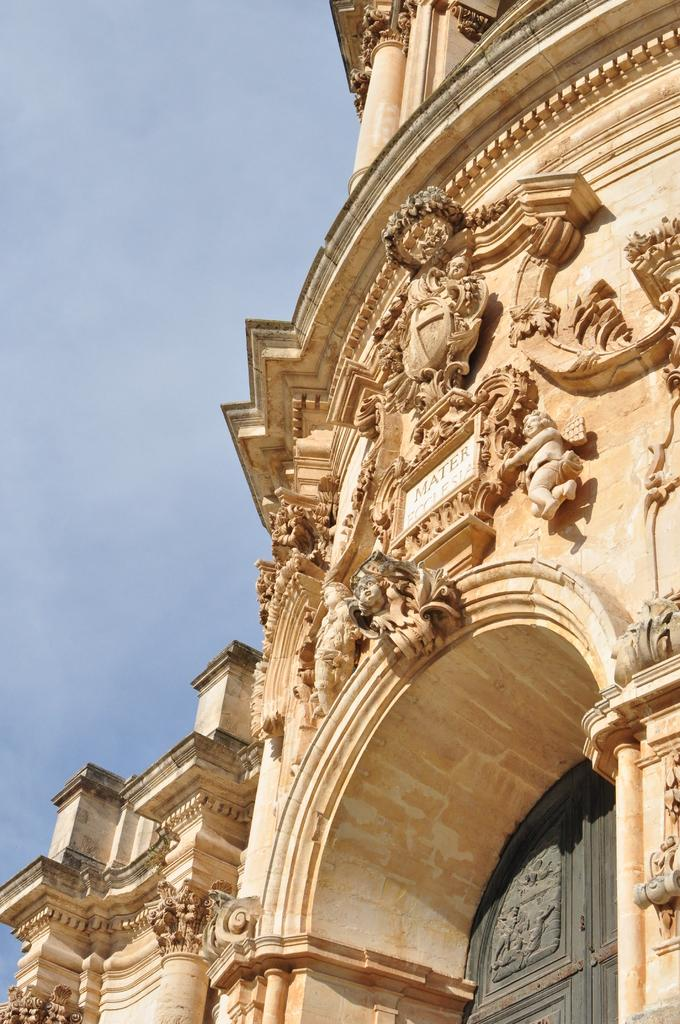What is the main structure in the image? There is a building in the image. What decorative elements can be seen on the building? Sculptures are engraved on the building. What can be seen in the background of the image? There is sky visible in the background of the image. What type of cast can be seen on the building in the image? There is no cast present on the building in the image. How many clams are visible on the sculptures in the image? There are no clams present on the sculptures in the image. 